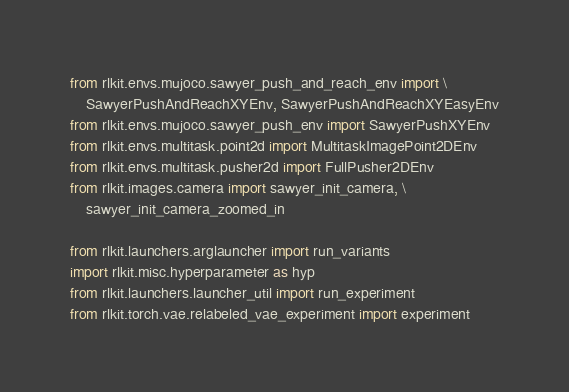<code> <loc_0><loc_0><loc_500><loc_500><_Python_>from rlkit.envs.mujoco.sawyer_push_and_reach_env import \
    SawyerPushAndReachXYEnv, SawyerPushAndReachXYEasyEnv
from rlkit.envs.mujoco.sawyer_push_env import SawyerPushXYEnv
from rlkit.envs.multitask.point2d import MultitaskImagePoint2DEnv
from rlkit.envs.multitask.pusher2d import FullPusher2DEnv
from rlkit.images.camera import sawyer_init_camera, \
    sawyer_init_camera_zoomed_in

from rlkit.launchers.arglauncher import run_variants
import rlkit.misc.hyperparameter as hyp
from rlkit.launchers.launcher_util import run_experiment
from rlkit.torch.vae.relabeled_vae_experiment import experiment
</code> 